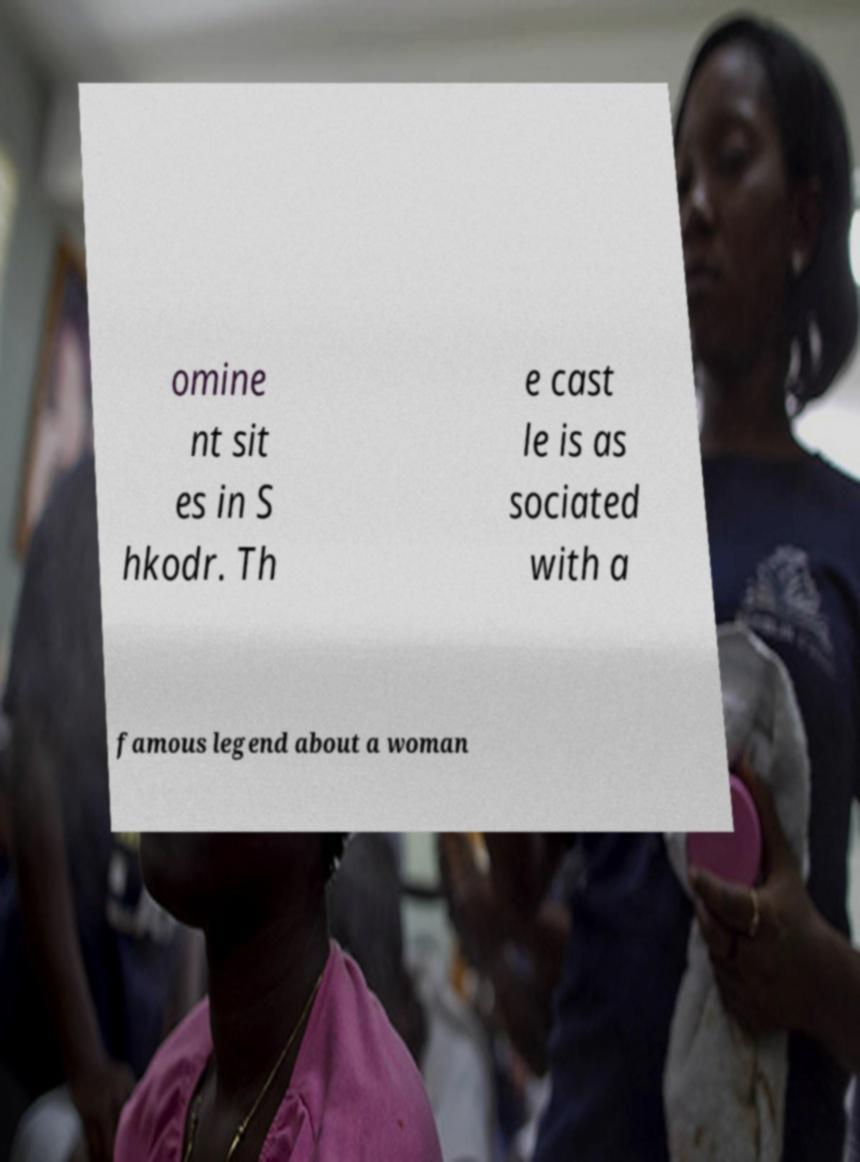Could you assist in decoding the text presented in this image and type it out clearly? omine nt sit es in S hkodr. Th e cast le is as sociated with a famous legend about a woman 